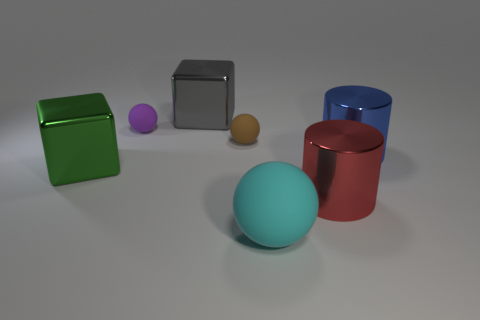The shiny block that is behind the purple rubber thing is what color?
Provide a short and direct response. Gray. Do the large rubber object and the big shiny thing that is in front of the large green block have the same color?
Provide a succinct answer. No. Are there fewer big red shiny cylinders than purple cylinders?
Your answer should be compact. No. Do the metal cylinder that is behind the large red cylinder and the big rubber ball have the same color?
Give a very brief answer. No. What number of green blocks have the same size as the gray metallic block?
Ensure brevity in your answer.  1. Are there any big rubber objects of the same color as the big matte ball?
Provide a succinct answer. No. Does the small purple ball have the same material as the gray thing?
Offer a very short reply. No. What number of green objects have the same shape as the red metallic object?
Provide a succinct answer. 0. There is a small brown thing that is made of the same material as the large cyan thing; what is its shape?
Your answer should be compact. Sphere. What is the color of the shiny object behind the metal cylinder to the right of the big red thing?
Keep it short and to the point. Gray. 